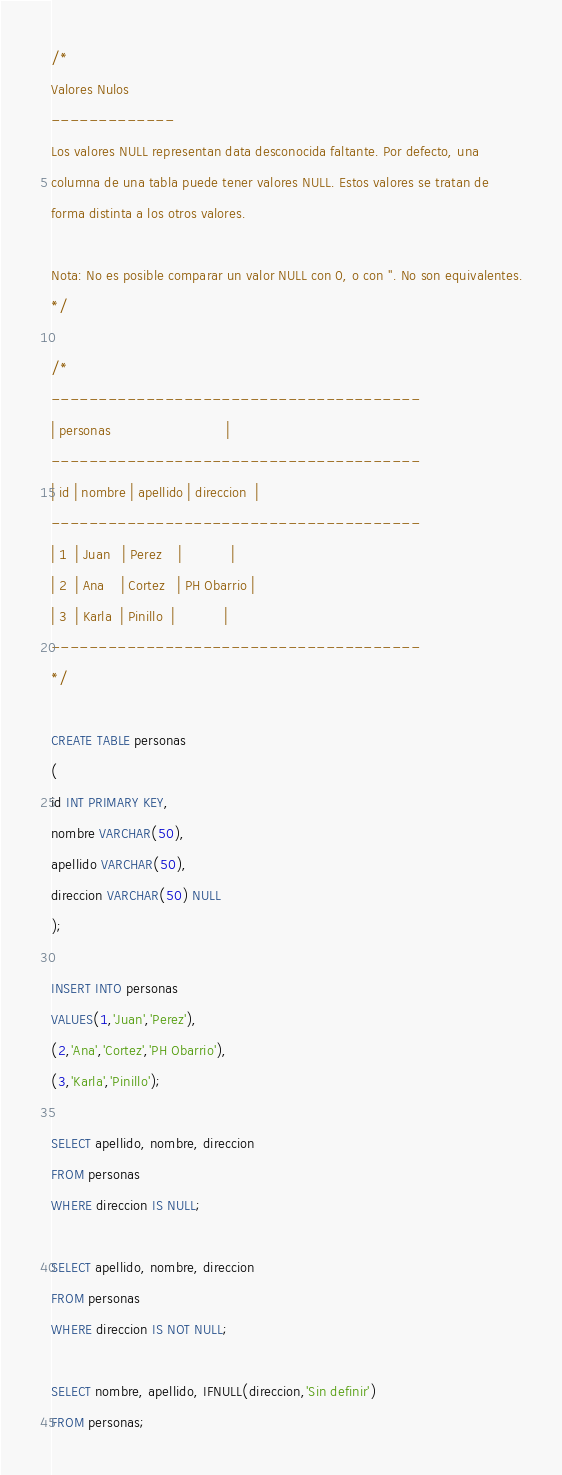Convert code to text. <code><loc_0><loc_0><loc_500><loc_500><_SQL_>/*
Valores Nulos
-------------
Los valores NULL representan data desconocida faltante. Por defecto, una
columna de una tabla puede tener valores NULL. Estos valores se tratan de
forma distinta a los otros valores.

Nota: No es posible comparar un valor NULL con 0, o con ''. No son equivalentes.
*/

/*
---------------------------------------
| personas                            |
---------------------------------------
| id | nombre | apellido | direccion  |
---------------------------------------
| 1  | Juan   | Perez    |            |
| 2  | Ana    | Cortez   | PH Obarrio |
| 3  | Karla  | Pinillo  |            |
---------------------------------------
*/

CREATE TABLE personas
(
id INT PRIMARY KEY,
nombre VARCHAR(50),
apellido VARCHAR(50),
direccion VARCHAR(50) NULL
);

INSERT INTO personas
VALUES(1,'Juan','Perez'),
(2,'Ana','Cortez','PH Obarrio'),
(3,'Karla','Pinillo');

SELECT apellido, nombre, direccion
FROM personas
WHERE direccion IS NULL;

SELECT apellido, nombre, direccion
FROM personas
WHERE direccion IS NOT NULL;

SELECT nombre, apellido, IFNULL(direccion,'Sin definir')
FROM personas;
</code> 